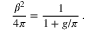<formula> <loc_0><loc_0><loc_500><loc_500>\frac { \beta ^ { 2 } } { 4 \pi } = \frac { 1 } { 1 + g / \pi } \, .</formula> 